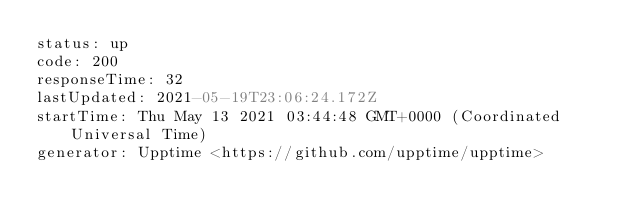Convert code to text. <code><loc_0><loc_0><loc_500><loc_500><_YAML_>status: up
code: 200
responseTime: 32
lastUpdated: 2021-05-19T23:06:24.172Z
startTime: Thu May 13 2021 03:44:48 GMT+0000 (Coordinated Universal Time)
generator: Upptime <https://github.com/upptime/upptime>
</code> 